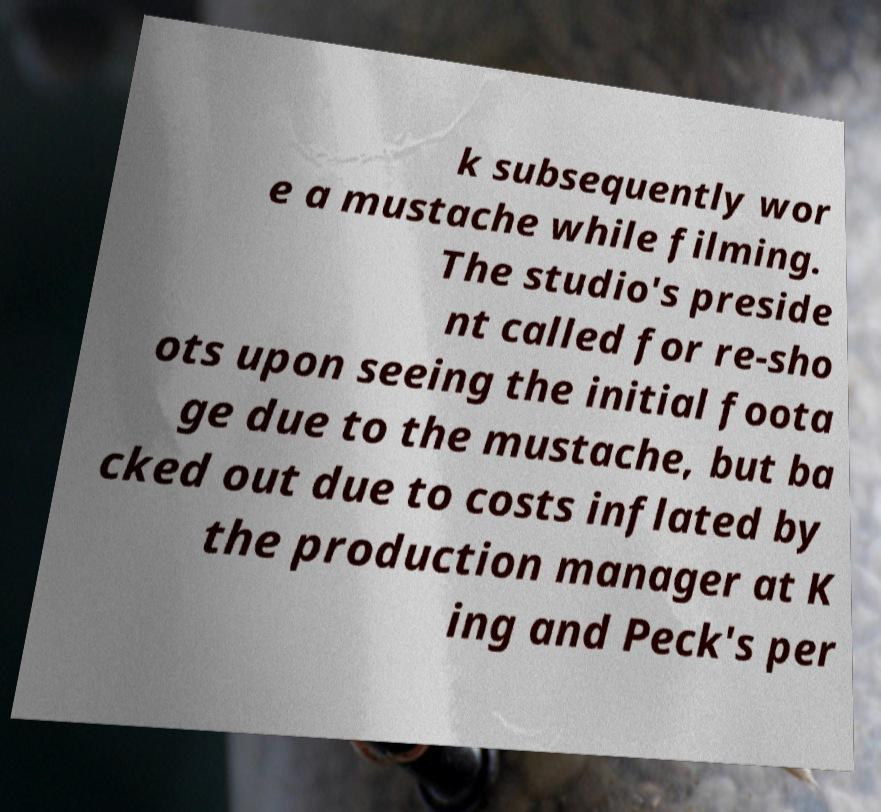What messages or text are displayed in this image? I need them in a readable, typed format. k subsequently wor e a mustache while filming. The studio's preside nt called for re-sho ots upon seeing the initial foota ge due to the mustache, but ba cked out due to costs inflated by the production manager at K ing and Peck's per 